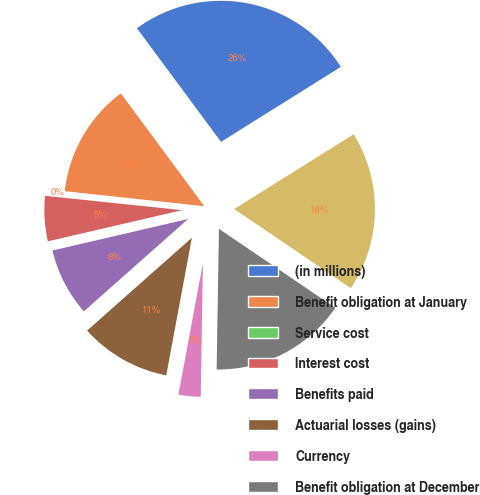Convert chart to OTSL. <chart><loc_0><loc_0><loc_500><loc_500><pie_chart><fcel>(in millions)<fcel>Benefit obligation at January<fcel>Service cost<fcel>Interest cost<fcel>Benefits paid<fcel>Actuarial losses (gains)<fcel>Currency<fcel>Benefit obligation at December<fcel>Net pension and postretirement<nl><fcel>26.24%<fcel>13.15%<fcel>0.05%<fcel>5.29%<fcel>7.91%<fcel>10.53%<fcel>2.67%<fcel>15.77%<fcel>18.39%<nl></chart> 